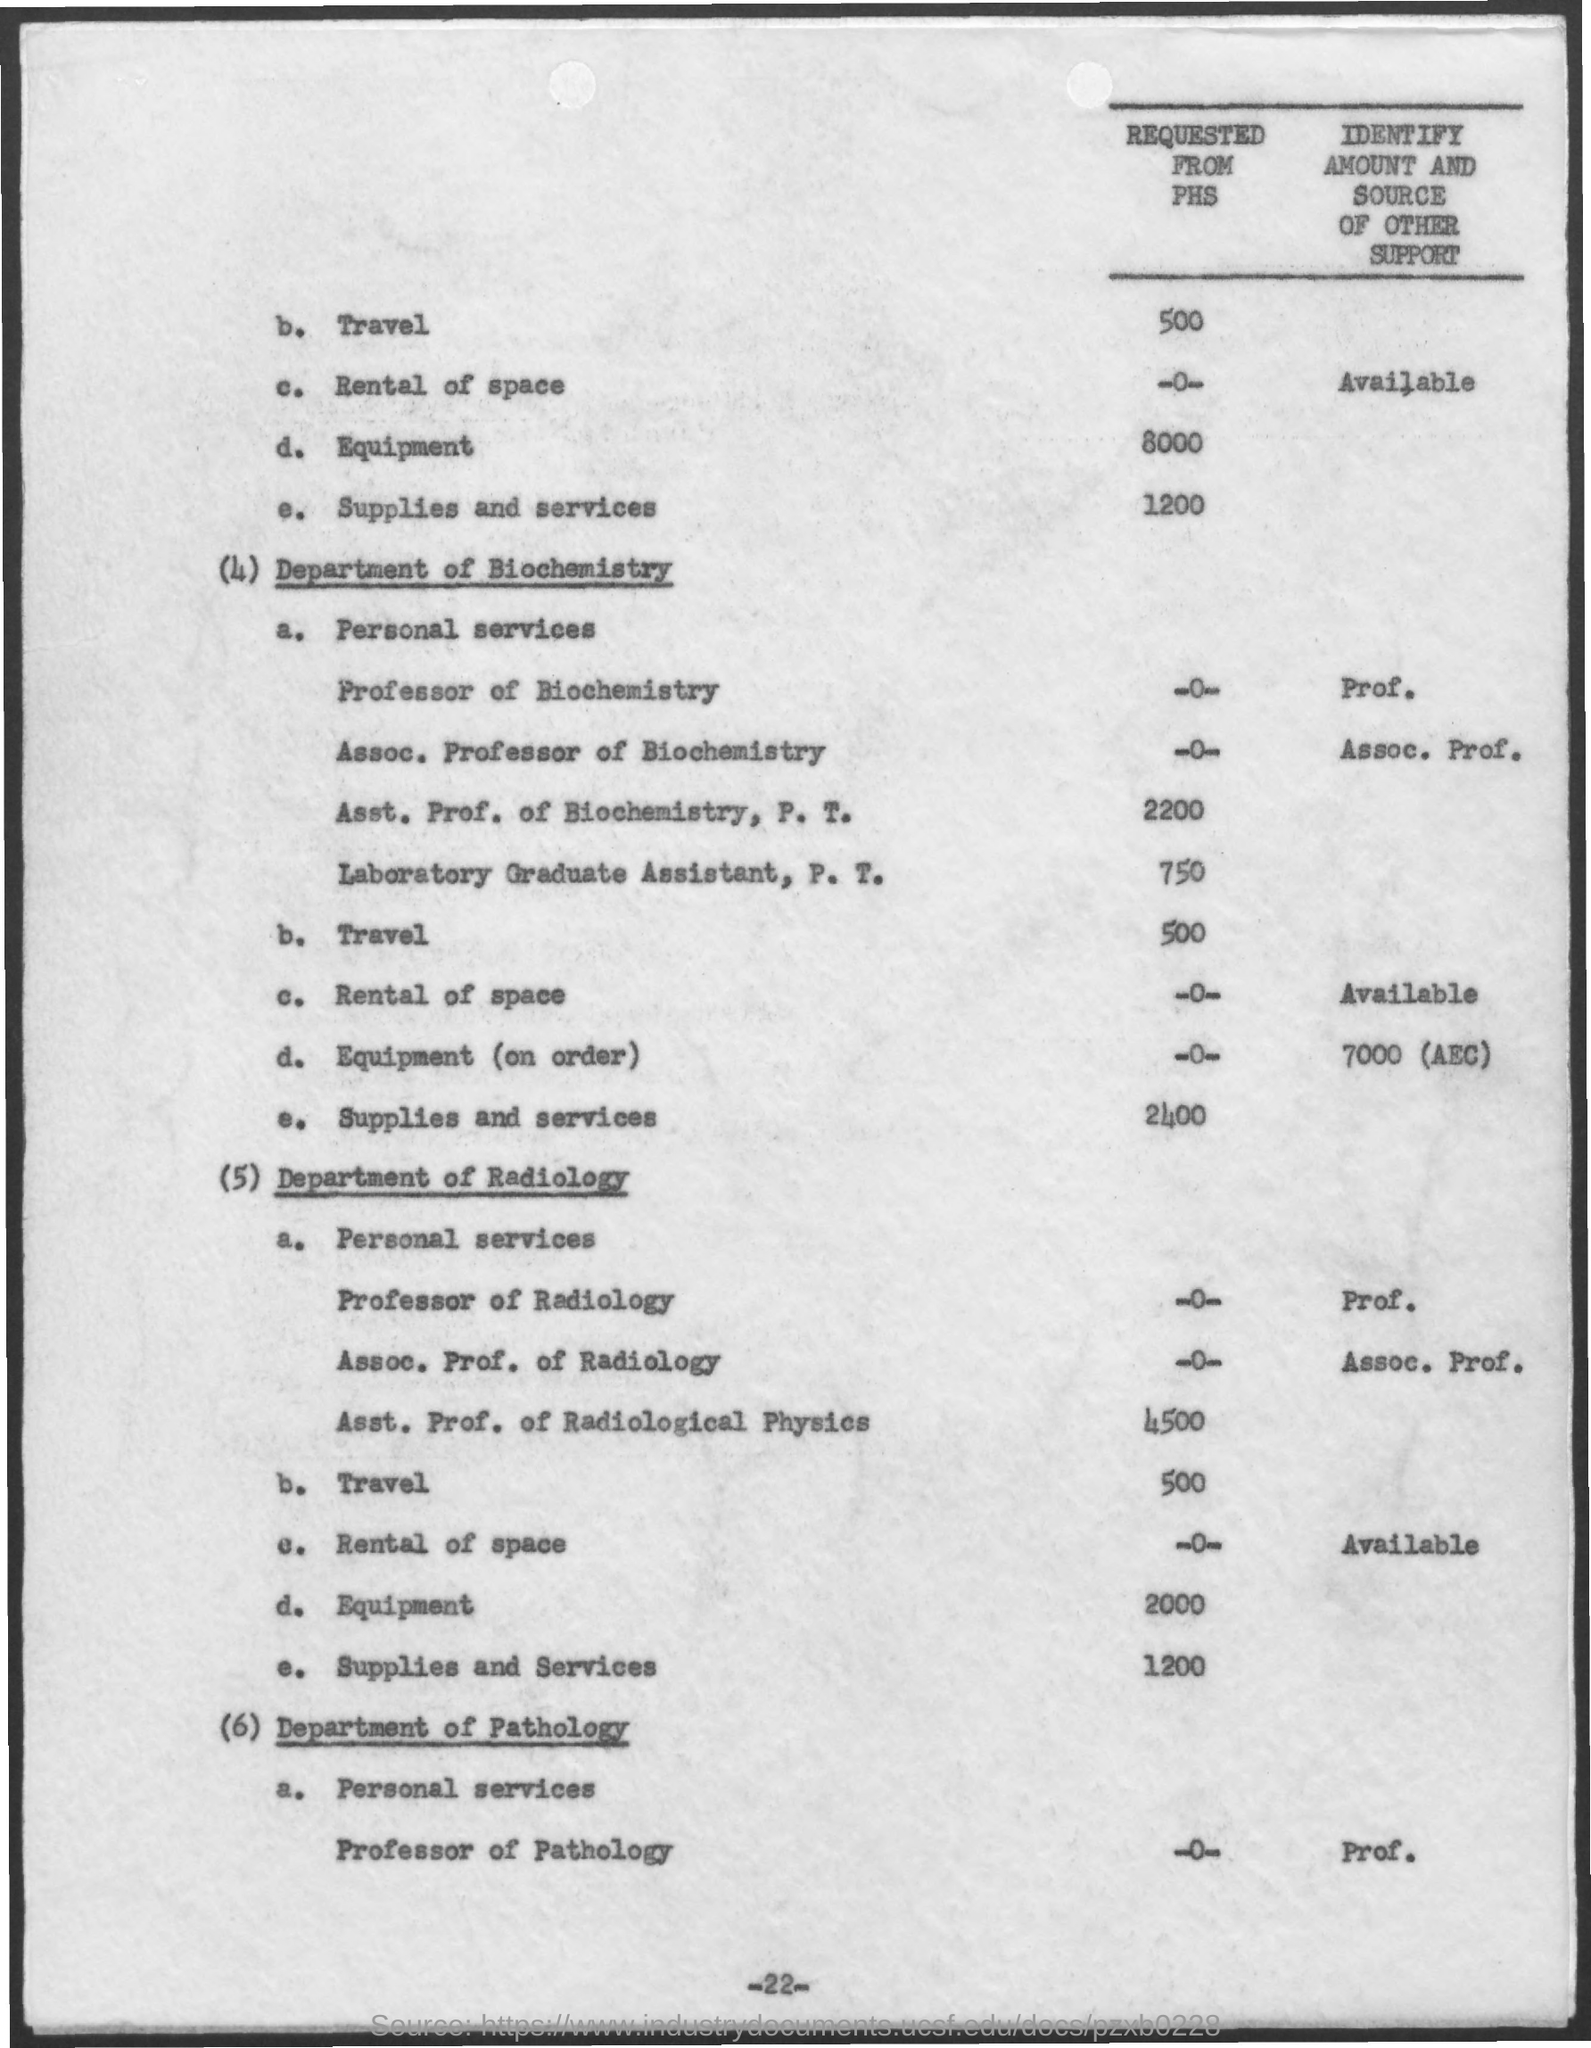Outline some significant characteristics in this image. The amount designated for supplies and services in the radiology department is $1,200. The amount mentioned for supplies and services in the Department of Biochemistry is 2,400. There is a mention of a travel amount of 500 in the department of radiology. 